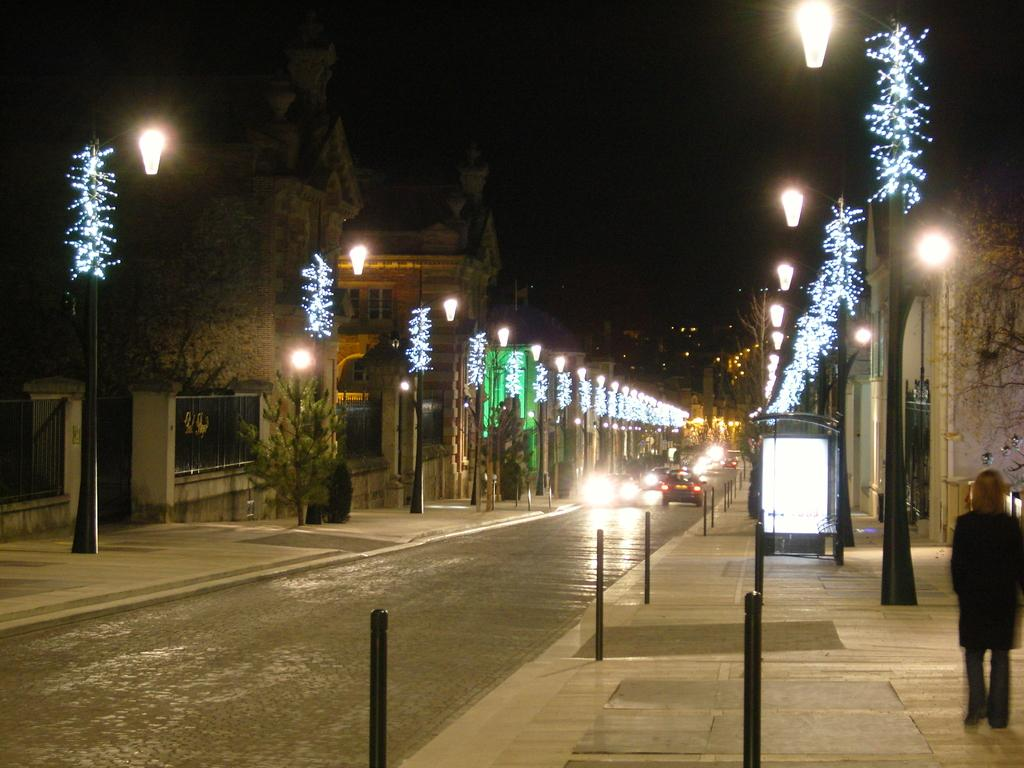What is happening on the road in the image? There are vehicles on the road in the image. Can you describe the person in the image? There is a person on the footpath in the image. What can be seen illuminating the scene in the image? There are lights visible in the image. What type of natural elements are present in the image? There are trees in the image. How would you describe the overall lighting in the image? The background of the image appears to be dark. What type of joke is being told by the trees in the image? There are no jokes being told in the image, and the trees do not have the ability to tell jokes. What force is causing the vehicles to move on the road in the image? The fact that the vehicles are moving on the road does not indicate a specific force; it could be due to various factors such as engines, gravity, or momentum. 